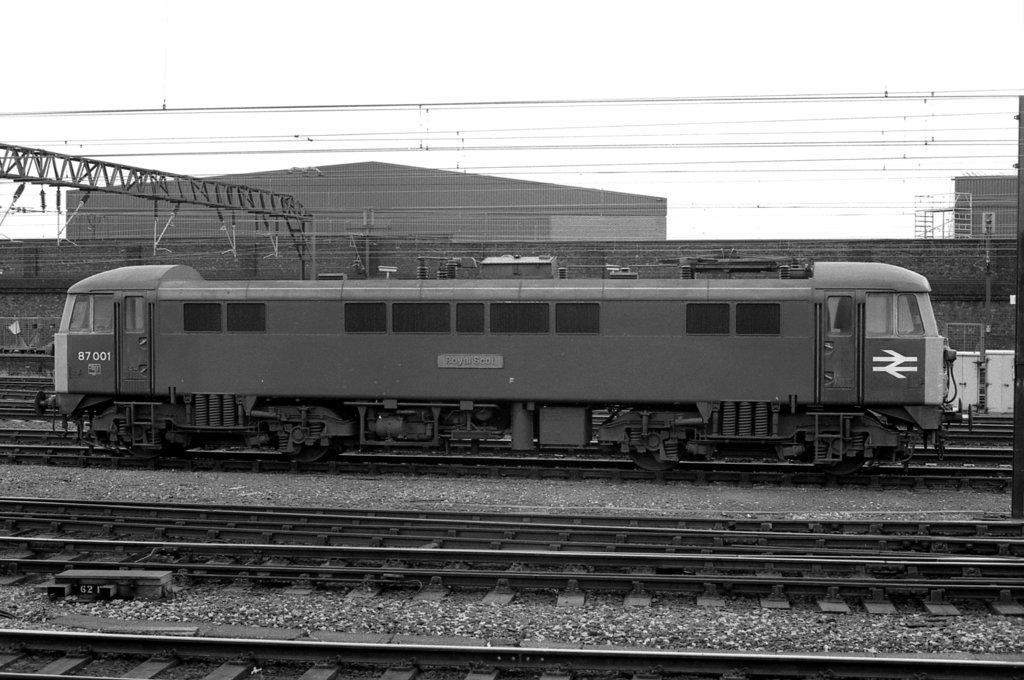What is the main subject of the image? The main subject of the image is a train. What is the train's position in relation to the ground? The train is on a track. What can be seen in the background of the image? There are poles and wires associated with the poles in the background of the image. What type of leather material can be seen on the train in the image? There is no leather material visible on the train in the image. What kind of view can be seen from the train in the image? The image does not show a view from the train, as it is focused on the train itself and its surroundings. 